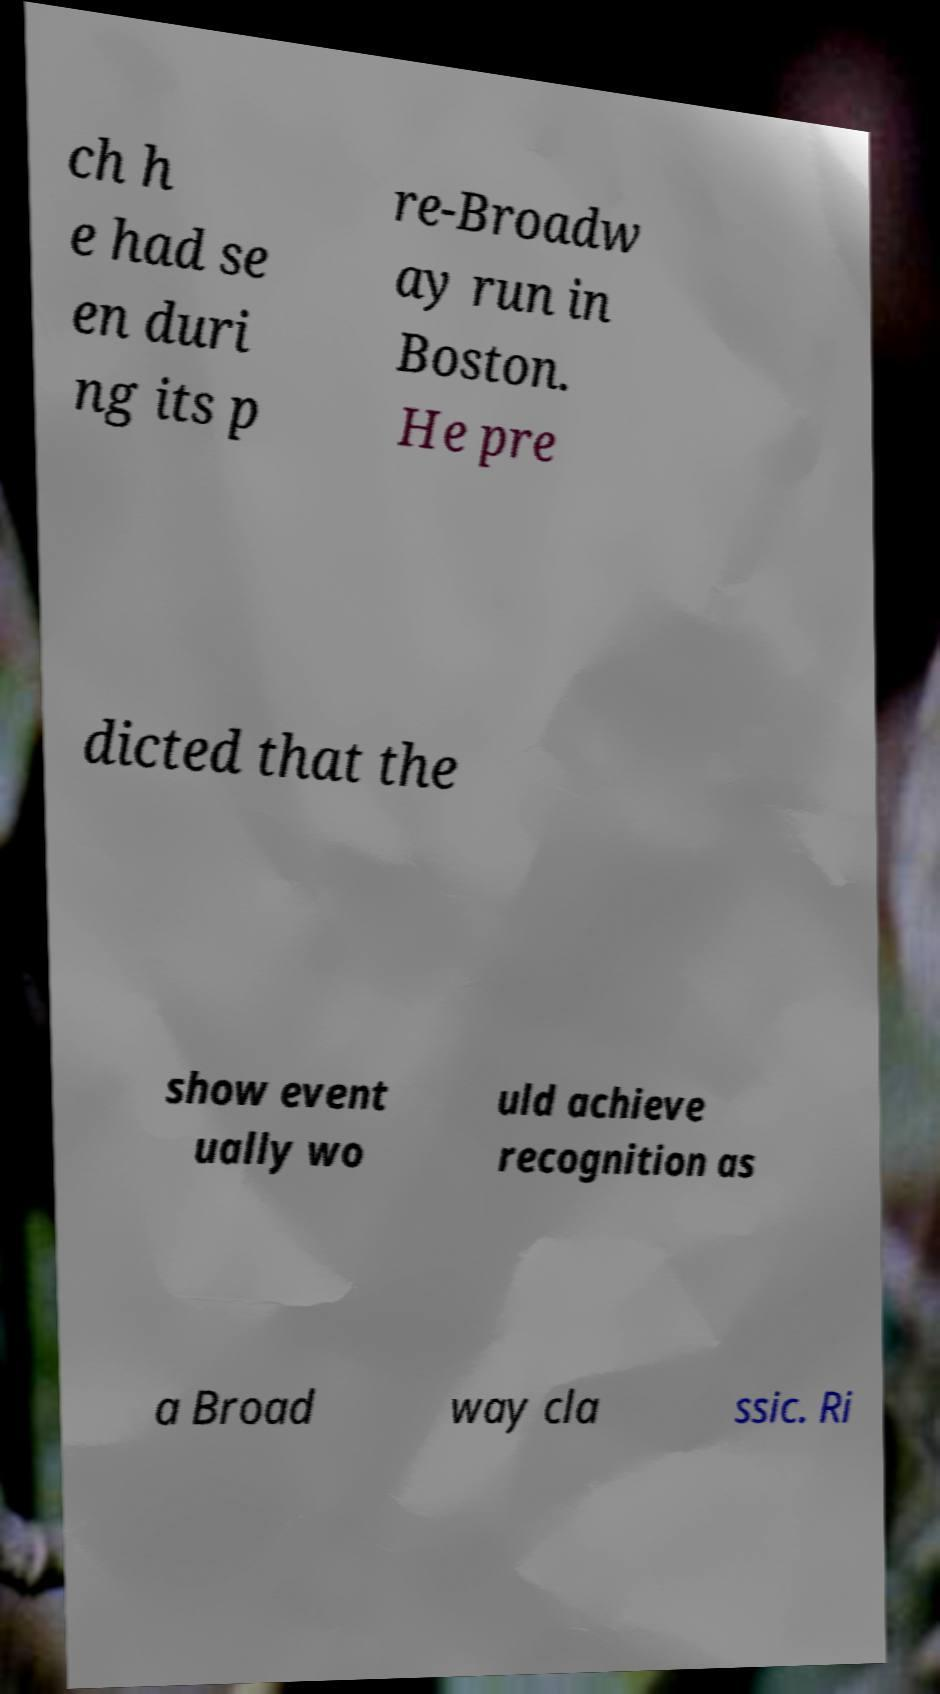Could you assist in decoding the text presented in this image and type it out clearly? ch h e had se en duri ng its p re-Broadw ay run in Boston. He pre dicted that the show event ually wo uld achieve recognition as a Broad way cla ssic. Ri 